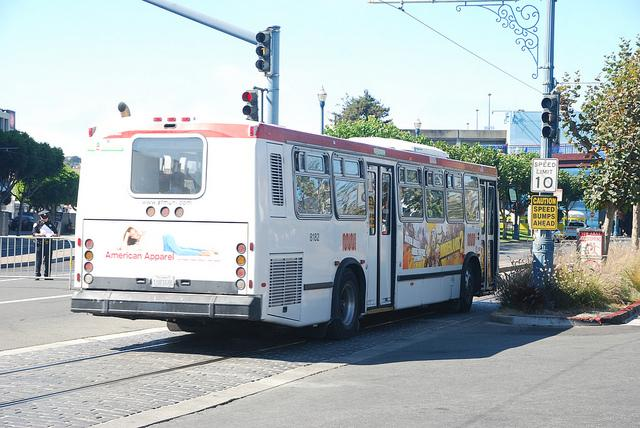Where is the bus located? side street 